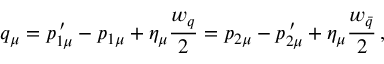<formula> <loc_0><loc_0><loc_500><loc_500>q _ { \mu } = p _ { 1 \mu } ^ { \, \prime } - p _ { 1 \mu } + \eta _ { \mu } \frac { w _ { q } } { 2 } = p _ { 2 \mu } - p _ { 2 \mu } ^ { \, \prime } + \eta _ { \mu } \frac { w _ { \bar { q } } } { 2 } \, ,</formula> 